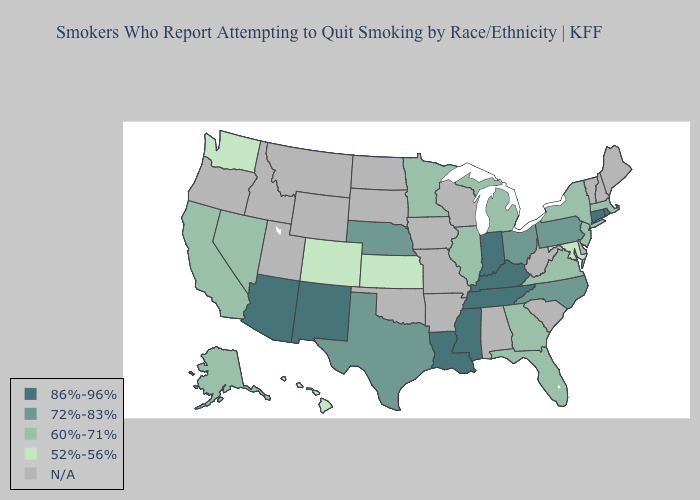What is the value of Kansas?
Concise answer only. 52%-56%. Which states hav the highest value in the MidWest?
Concise answer only. Indiana. Does Tennessee have the highest value in the USA?
Quick response, please. Yes. Name the states that have a value in the range 52%-56%?
Answer briefly. Colorado, Hawaii, Kansas, Maryland, Washington. What is the lowest value in the USA?
Keep it brief. 52%-56%. What is the highest value in the West ?
Be succinct. 86%-96%. What is the highest value in the USA?
Quick response, please. 86%-96%. What is the value of South Dakota?
Answer briefly. N/A. What is the value of Alabama?
Write a very short answer. N/A. Does Indiana have the highest value in the MidWest?
Answer briefly. Yes. Name the states that have a value in the range 60%-71%?
Keep it brief. Alaska, California, Florida, Georgia, Illinois, Massachusetts, Michigan, Minnesota, Nevada, New Jersey, New York, Virginia. What is the highest value in the West ?
Quick response, please. 86%-96%. What is the lowest value in the MidWest?
Keep it brief. 52%-56%. 